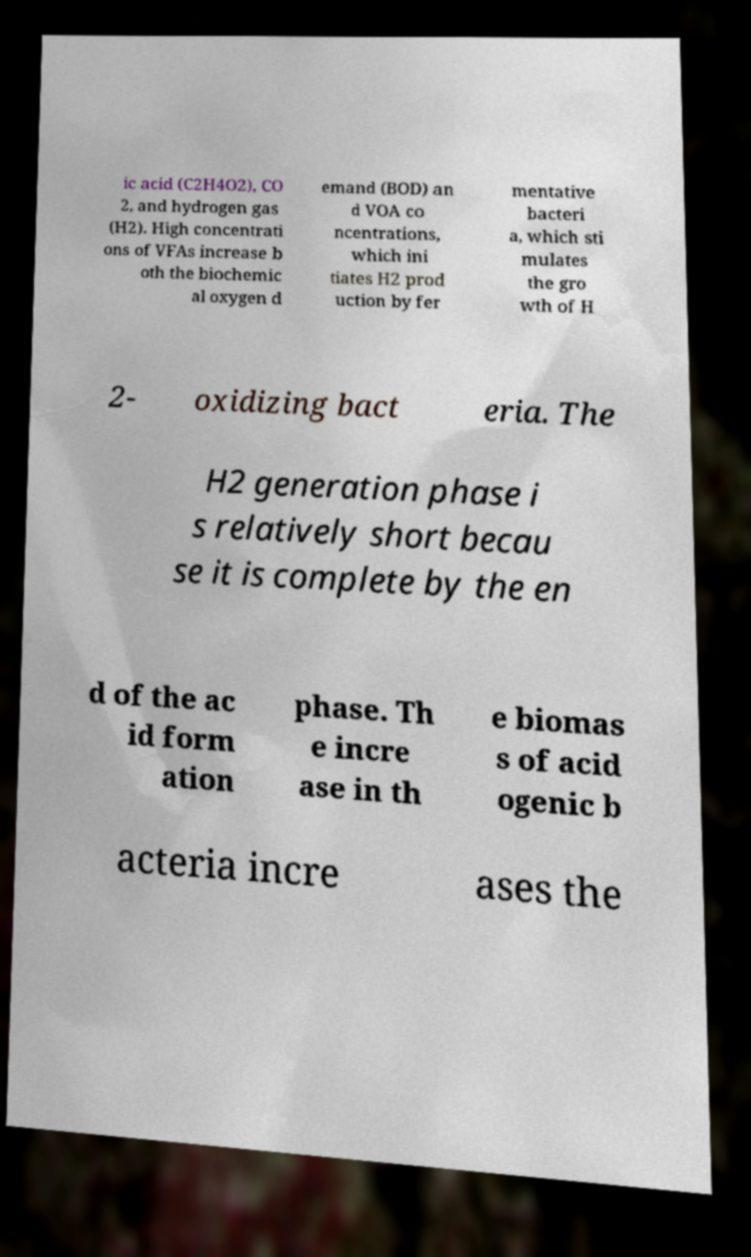What messages or text are displayed in this image? I need them in a readable, typed format. ic acid (C2H4O2), CO 2, and hydrogen gas (H2). High concentrati ons of VFAs increase b oth the biochemic al oxygen d emand (BOD) an d VOA co ncentrations, which ini tiates H2 prod uction by fer mentative bacteri a, which sti mulates the gro wth of H 2- oxidizing bact eria. The H2 generation phase i s relatively short becau se it is complete by the en d of the ac id form ation phase. Th e incre ase in th e biomas s of acid ogenic b acteria incre ases the 